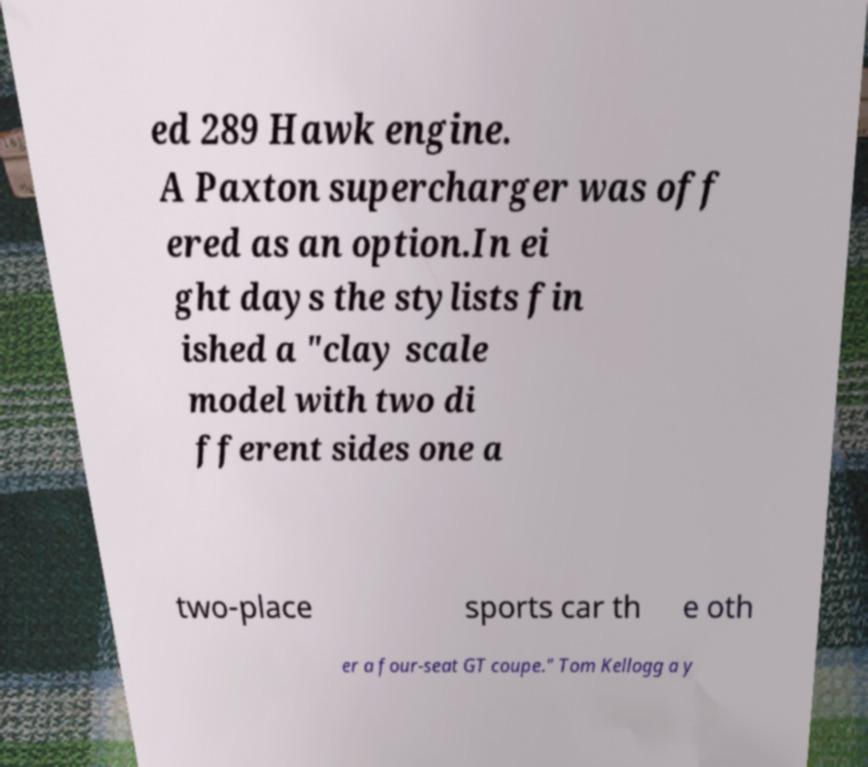What messages or text are displayed in this image? I need them in a readable, typed format. ed 289 Hawk engine. A Paxton supercharger was off ered as an option.In ei ght days the stylists fin ished a "clay scale model with two di fferent sides one a two-place sports car th e oth er a four-seat GT coupe." Tom Kellogg a y 